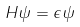<formula> <loc_0><loc_0><loc_500><loc_500>H \psi = \epsilon \psi</formula> 